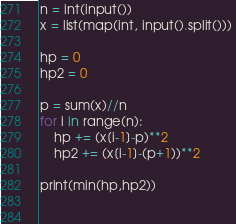<code> <loc_0><loc_0><loc_500><loc_500><_Python_>n = int(input())
x = list(map(int, input().split())) 

hp = 0
hp2 = 0

p = sum(x)//n
for i in range(n):
    hp += (x[i-1]-p)**2
    hp2 += (x[i-1]-(p+1))**2

print(min(hp,hp2))

    </code> 